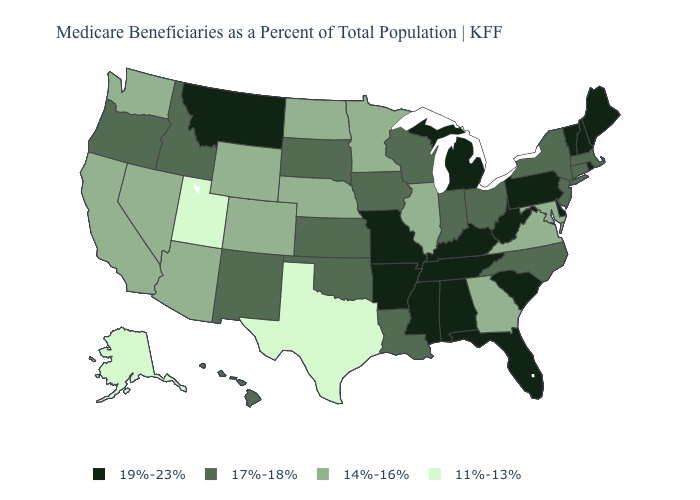Name the states that have a value in the range 17%-18%?
Concise answer only. Connecticut, Hawaii, Idaho, Indiana, Iowa, Kansas, Louisiana, Massachusetts, New Jersey, New Mexico, New York, North Carolina, Ohio, Oklahoma, Oregon, South Dakota, Wisconsin. Name the states that have a value in the range 11%-13%?
Short answer required. Alaska, Texas, Utah. What is the highest value in the USA?
Concise answer only. 19%-23%. Which states have the highest value in the USA?
Answer briefly. Alabama, Arkansas, Delaware, Florida, Kentucky, Maine, Michigan, Mississippi, Missouri, Montana, New Hampshire, Pennsylvania, Rhode Island, South Carolina, Tennessee, Vermont, West Virginia. Name the states that have a value in the range 17%-18%?
Quick response, please. Connecticut, Hawaii, Idaho, Indiana, Iowa, Kansas, Louisiana, Massachusetts, New Jersey, New Mexico, New York, North Carolina, Ohio, Oklahoma, Oregon, South Dakota, Wisconsin. What is the lowest value in states that border New Jersey?
Write a very short answer. 17%-18%. Name the states that have a value in the range 19%-23%?
Give a very brief answer. Alabama, Arkansas, Delaware, Florida, Kentucky, Maine, Michigan, Mississippi, Missouri, Montana, New Hampshire, Pennsylvania, Rhode Island, South Carolina, Tennessee, Vermont, West Virginia. How many symbols are there in the legend?
Answer briefly. 4. Among the states that border Rhode Island , which have the highest value?
Concise answer only. Connecticut, Massachusetts. What is the lowest value in states that border Wyoming?
Be succinct. 11%-13%. Name the states that have a value in the range 19%-23%?
Keep it brief. Alabama, Arkansas, Delaware, Florida, Kentucky, Maine, Michigan, Mississippi, Missouri, Montana, New Hampshire, Pennsylvania, Rhode Island, South Carolina, Tennessee, Vermont, West Virginia. Does Maine have the highest value in the Northeast?
Concise answer only. Yes. What is the value of Idaho?
Answer briefly. 17%-18%. Among the states that border Delaware , does Maryland have the lowest value?
Short answer required. Yes. What is the value of Oregon?
Write a very short answer. 17%-18%. 